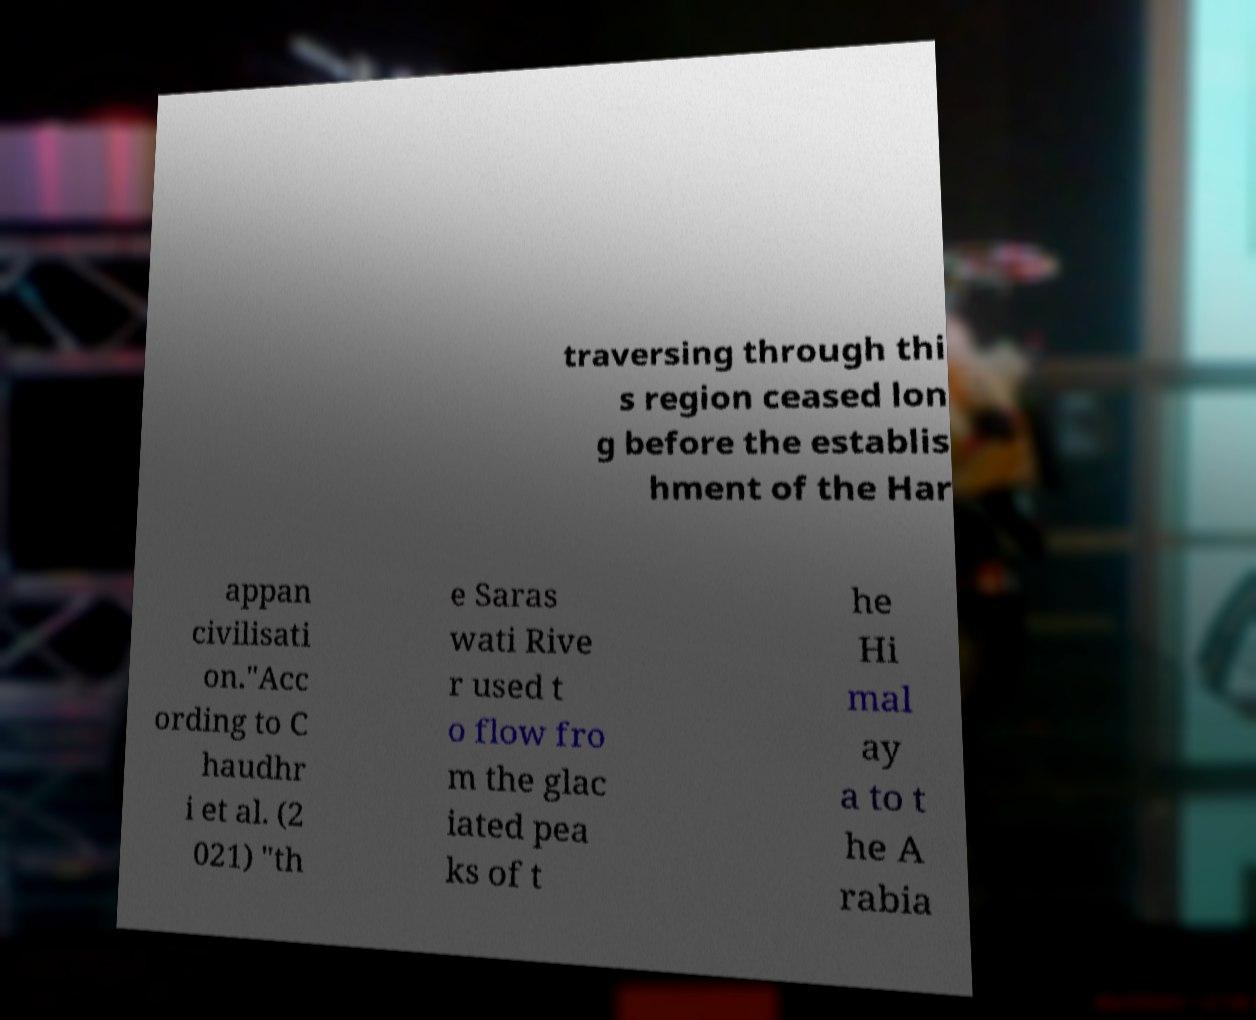What messages or text are displayed in this image? I need them in a readable, typed format. traversing through thi s region ceased lon g before the establis hment of the Har appan civilisati on."Acc ording to C haudhr i et al. (2 021) "th e Saras wati Rive r used t o flow fro m the glac iated pea ks of t he Hi mal ay a to t he A rabia 